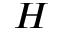Convert formula to latex. <formula><loc_0><loc_0><loc_500><loc_500>H</formula> 